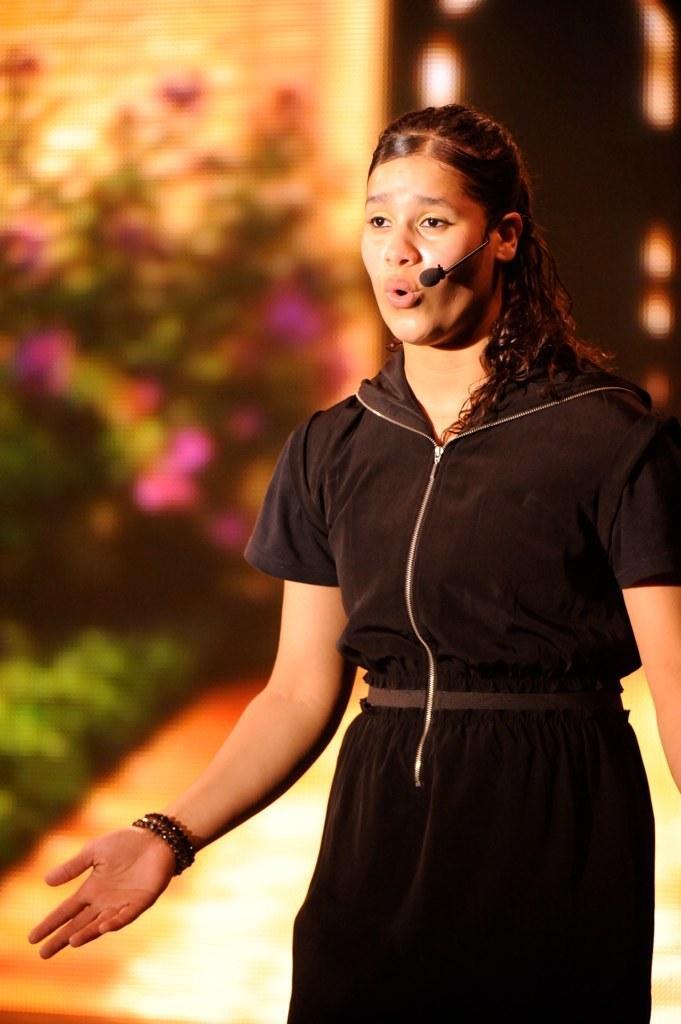Can you describe this image briefly? On the right side of the image we can see a lady is standing and wearing a black dress, mix and talking. In the background of the image we can see the plants, flowers, wall, door. At the bottom of the image we can see the floor. 